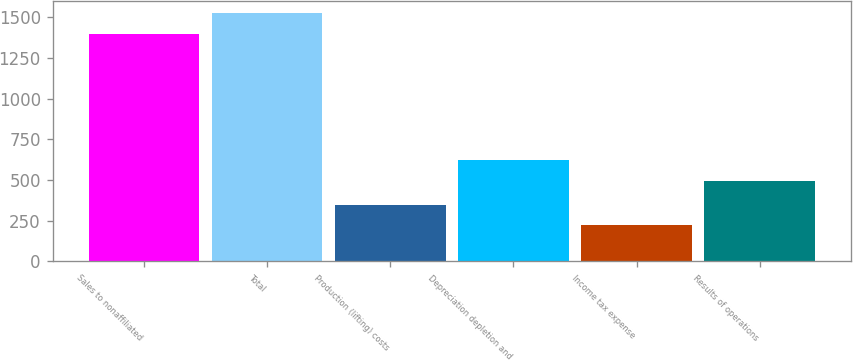<chart> <loc_0><loc_0><loc_500><loc_500><bar_chart><fcel>Sales to nonaffiliated<fcel>Total<fcel>Production (lifting) costs<fcel>Depreciation depletion and<fcel>Income tax expense<fcel>Results of operations<nl><fcel>1396<fcel>1523.1<fcel>349.1<fcel>624.1<fcel>222<fcel>497<nl></chart> 